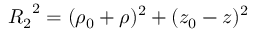<formula> <loc_0><loc_0><loc_500><loc_500>{ R _ { 2 } } ^ { 2 } = ( \rho _ { 0 } + \rho ) ^ { 2 } + ( z _ { 0 } - z ) ^ { 2 }</formula> 